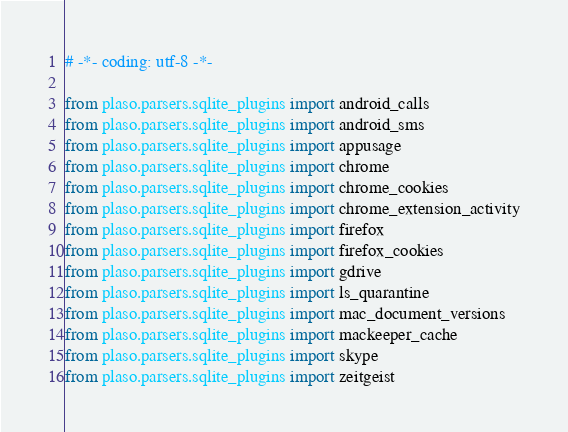<code> <loc_0><loc_0><loc_500><loc_500><_Python_># -*- coding: utf-8 -*-

from plaso.parsers.sqlite_plugins import android_calls
from plaso.parsers.sqlite_plugins import android_sms
from plaso.parsers.sqlite_plugins import appusage
from plaso.parsers.sqlite_plugins import chrome
from plaso.parsers.sqlite_plugins import chrome_cookies
from plaso.parsers.sqlite_plugins import chrome_extension_activity
from plaso.parsers.sqlite_plugins import firefox
from plaso.parsers.sqlite_plugins import firefox_cookies
from plaso.parsers.sqlite_plugins import gdrive
from plaso.parsers.sqlite_plugins import ls_quarantine
from plaso.parsers.sqlite_plugins import mac_document_versions
from plaso.parsers.sqlite_plugins import mackeeper_cache
from plaso.parsers.sqlite_plugins import skype
from plaso.parsers.sqlite_plugins import zeitgeist
</code> 